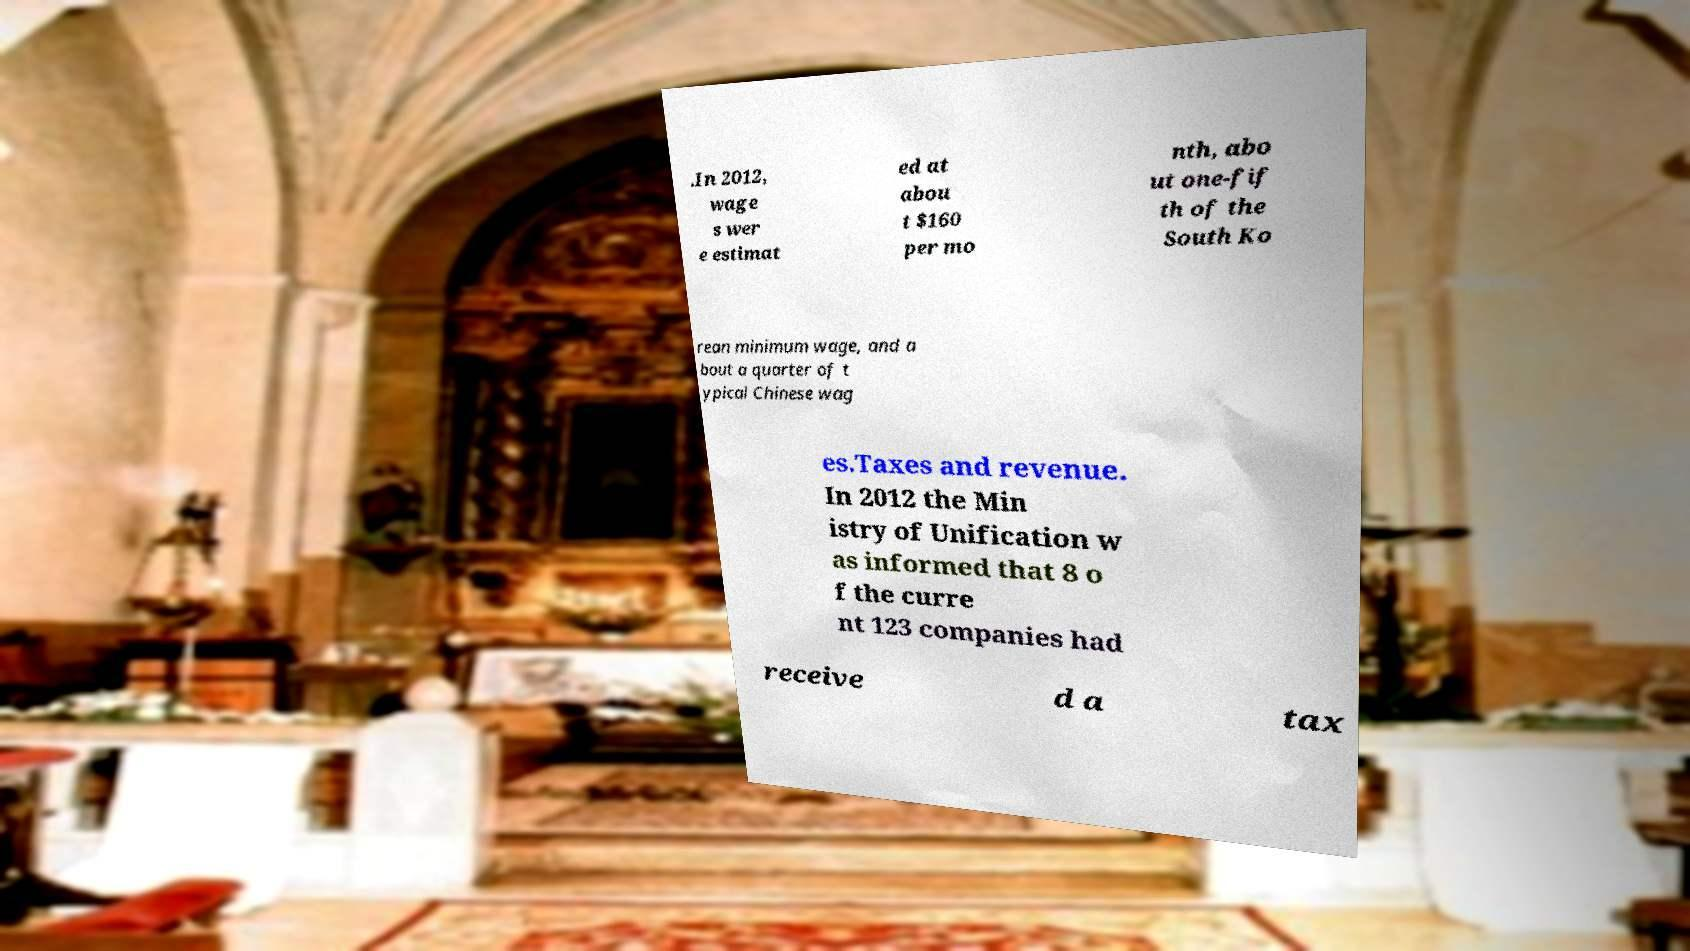For documentation purposes, I need the text within this image transcribed. Could you provide that? .In 2012, wage s wer e estimat ed at abou t $160 per mo nth, abo ut one-fif th of the South Ko rean minimum wage, and a bout a quarter of t ypical Chinese wag es.Taxes and revenue. In 2012 the Min istry of Unification w as informed that 8 o f the curre nt 123 companies had receive d a tax 